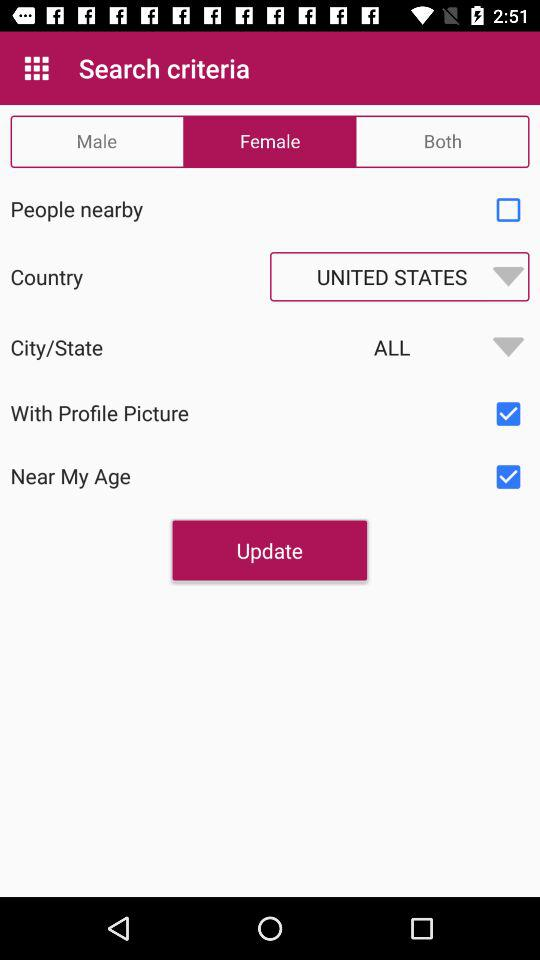What is the status of "With Profile Picture"? The status is "on". 